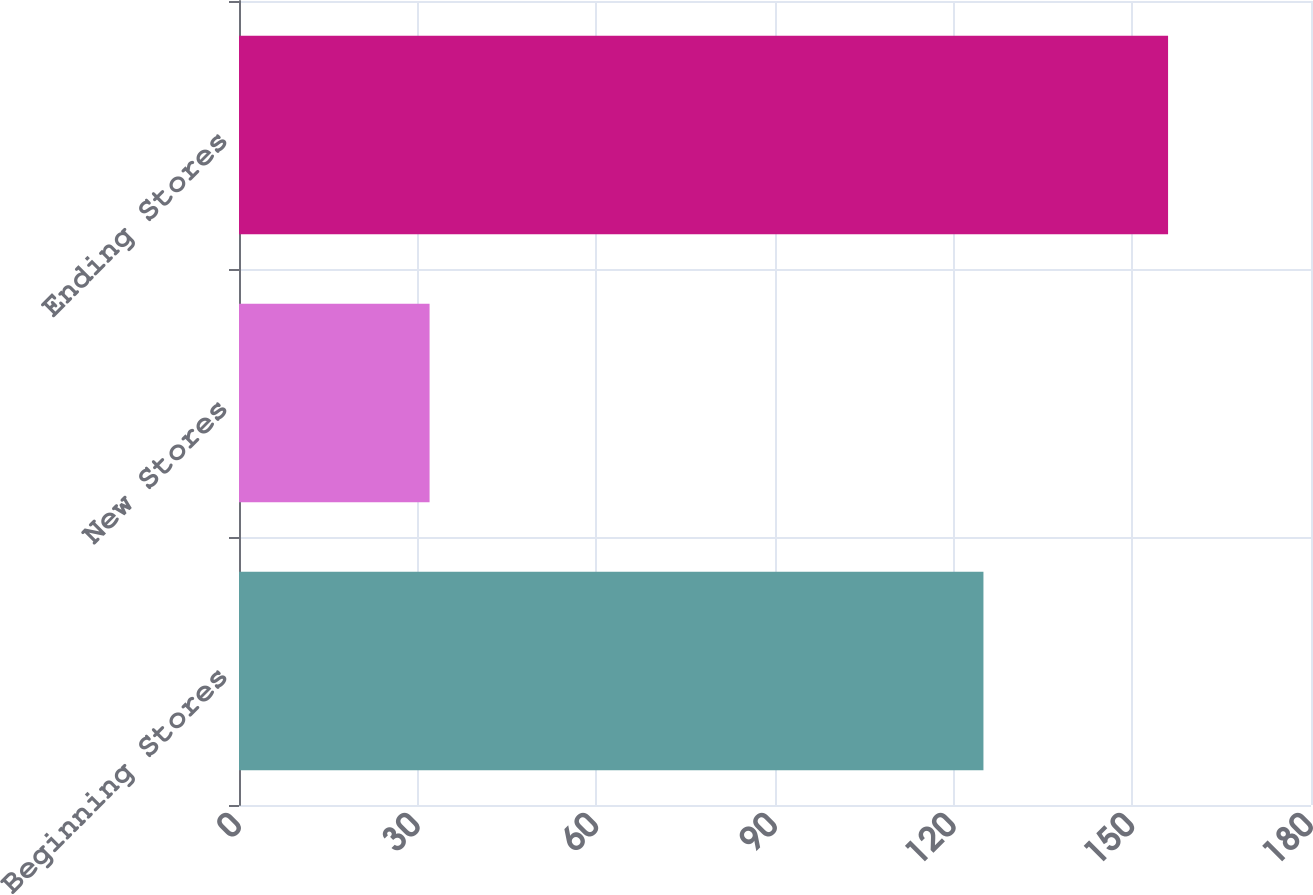<chart> <loc_0><loc_0><loc_500><loc_500><bar_chart><fcel>Beginning Stores<fcel>New Stores<fcel>Ending Stores<nl><fcel>125<fcel>32<fcel>156<nl></chart> 